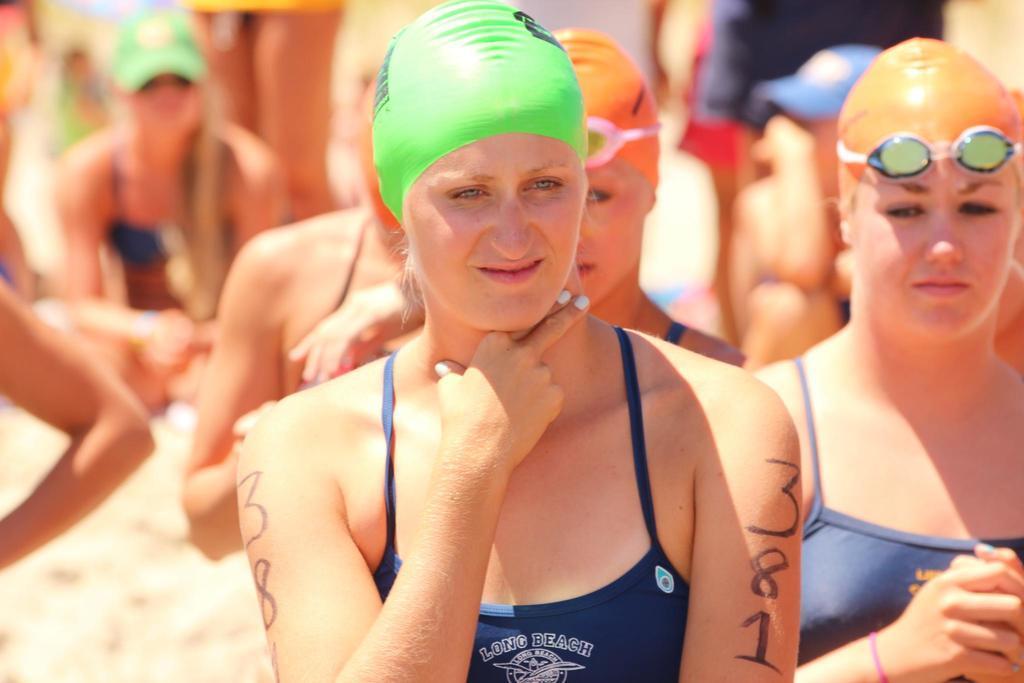Describe this image in one or two sentences. In this image we can see a group of woman standing. We can also see some women sitting on the ground wearing the caps. 